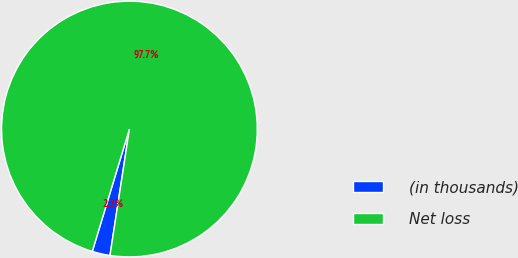Convert chart. <chart><loc_0><loc_0><loc_500><loc_500><pie_chart><fcel>(in thousands)<fcel>Net loss<nl><fcel>2.26%<fcel>97.74%<nl></chart> 